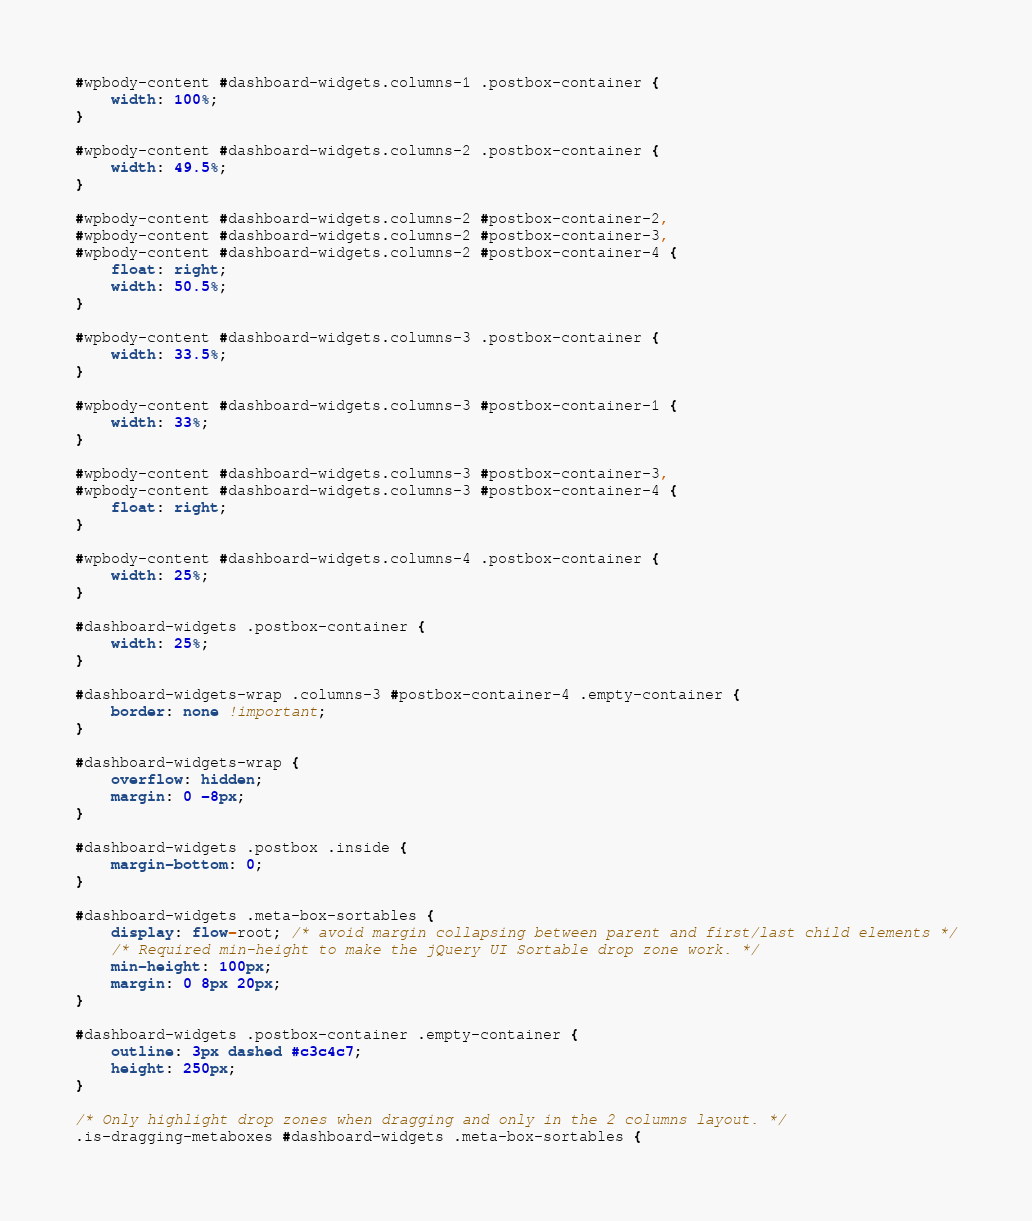<code> <loc_0><loc_0><loc_500><loc_500><_CSS_>#wpbody-content #dashboard-widgets.columns-1 .postbox-container {
	width: 100%;
}

#wpbody-content #dashboard-widgets.columns-2 .postbox-container {
	width: 49.5%;
}

#wpbody-content #dashboard-widgets.columns-2 #postbox-container-2,
#wpbody-content #dashboard-widgets.columns-2 #postbox-container-3,
#wpbody-content #dashboard-widgets.columns-2 #postbox-container-4 {
	float: right;
	width: 50.5%;
}

#wpbody-content #dashboard-widgets.columns-3 .postbox-container {
	width: 33.5%;
}

#wpbody-content #dashboard-widgets.columns-3 #postbox-container-1 {
	width: 33%;
}

#wpbody-content #dashboard-widgets.columns-3 #postbox-container-3,
#wpbody-content #dashboard-widgets.columns-3 #postbox-container-4 {
	float: right;
}

#wpbody-content #dashboard-widgets.columns-4 .postbox-container {
	width: 25%;
}

#dashboard-widgets .postbox-container {
	width: 25%;
}

#dashboard-widgets-wrap .columns-3 #postbox-container-4 .empty-container {
	border: none !important;
}

#dashboard-widgets-wrap {
	overflow: hidden;
	margin: 0 -8px;
}

#dashboard-widgets .postbox .inside {
	margin-bottom: 0;
}

#dashboard-widgets .meta-box-sortables {
	display: flow-root; /* avoid margin collapsing between parent and first/last child elements */
	/* Required min-height to make the jQuery UI Sortable drop zone work. */
	min-height: 100px;
	margin: 0 8px 20px;
}

#dashboard-widgets .postbox-container .empty-container {
	outline: 3px dashed #c3c4c7;
	height: 250px;
}

/* Only highlight drop zones when dragging and only in the 2 columns layout. */
.is-dragging-metaboxes #dashboard-widgets .meta-box-sortables {</code> 